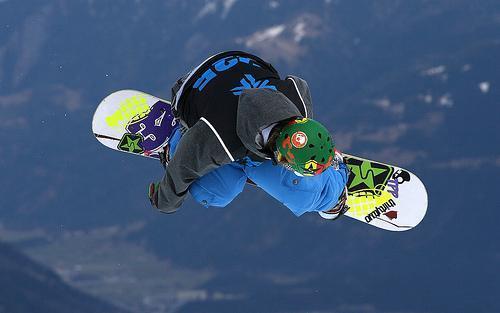How many people are in the photo?
Give a very brief answer. 1. 